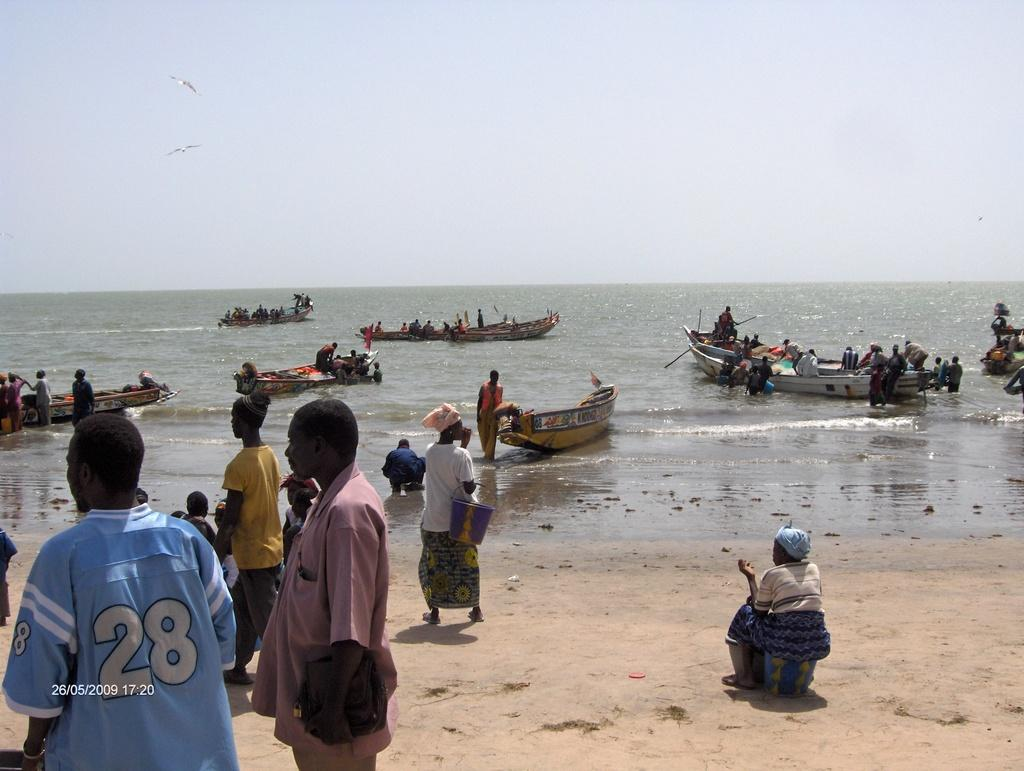What is the main subject of the image? The main subject of the image is a boat. Where is the boat located? The boat is on the water. Are there any people in the boat? Yes, there are people sitting in the boat. What else can be seen in the image? There are other people in the left corner of the image. What type of pencil is being used by the people in the boat? There is no pencil present in the image; it is a boat on the water with people sitting in it. 